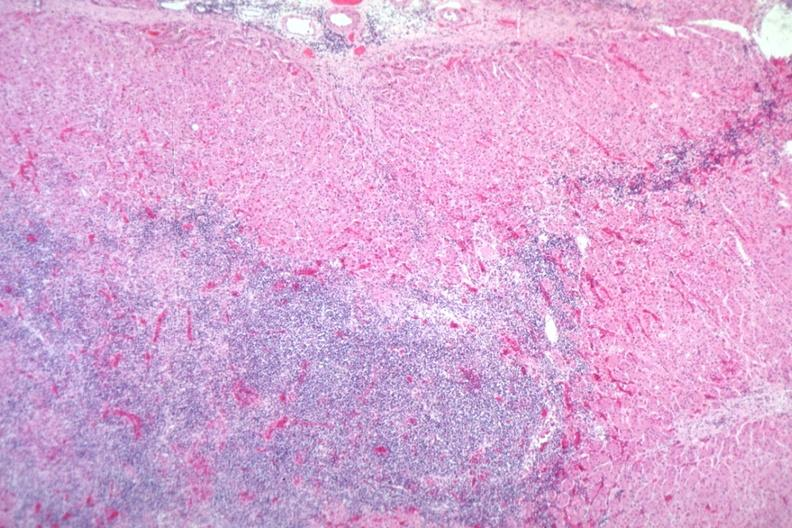s adrenal present?
Answer the question using a single word or phrase. Yes 